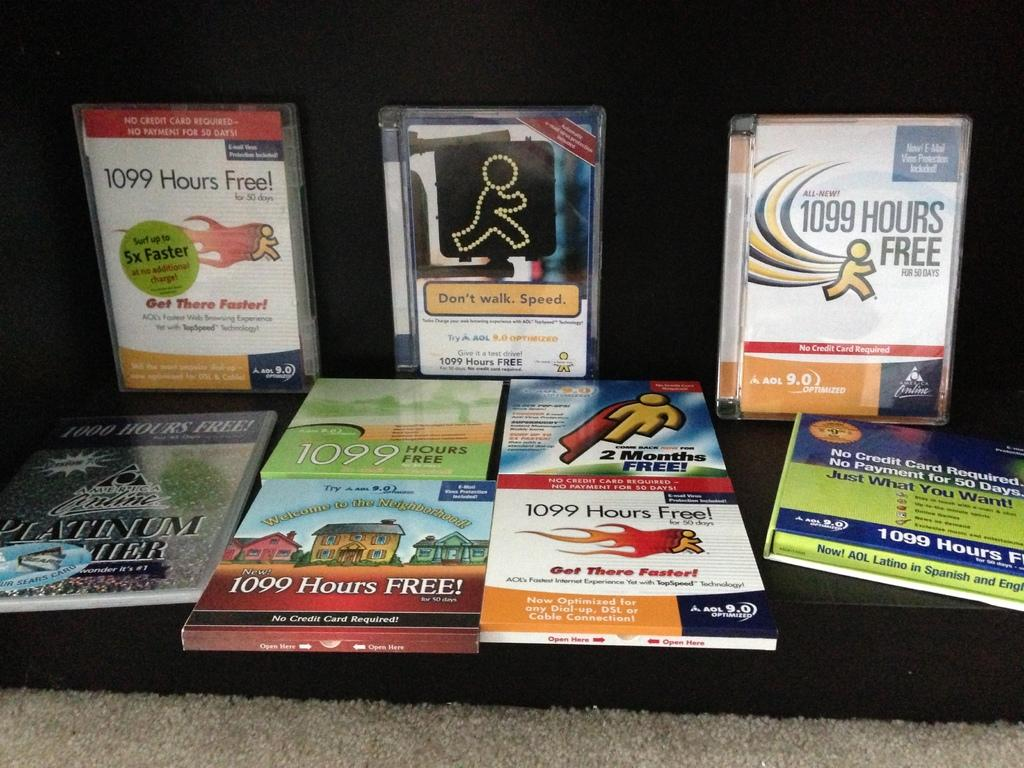<image>
Render a clear and concise summary of the photo. A display of CD cases and books for AOL features 1099 hours free is on display in front of a black box 